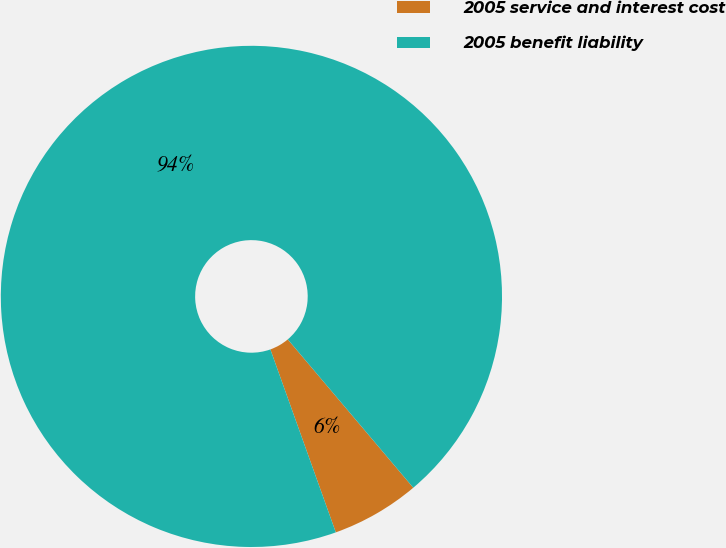<chart> <loc_0><loc_0><loc_500><loc_500><pie_chart><fcel>2005 service and interest cost<fcel>2005 benefit liability<nl><fcel>5.71%<fcel>94.29%<nl></chart> 